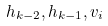<formula> <loc_0><loc_0><loc_500><loc_500>h _ { k - 2 } , h _ { k - 1 } , v _ { i }</formula> 